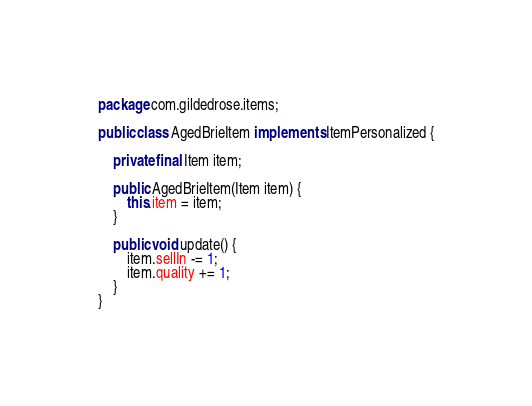<code> <loc_0><loc_0><loc_500><loc_500><_Java_>package com.gildedrose.items;

public class AgedBrieItem implements ItemPersonalized {

    private final Item item;

    public AgedBrieItem(Item item) {
        this.item = item;
    }

    public void update() {
        item.sellIn -= 1;
        item.quality += 1;
    }
}
</code> 